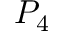<formula> <loc_0><loc_0><loc_500><loc_500>P _ { 4 }</formula> 